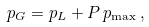Convert formula to latex. <formula><loc_0><loc_0><loc_500><loc_500>p _ { G } = p _ { L } + P \, p _ { \max } \, ,</formula> 